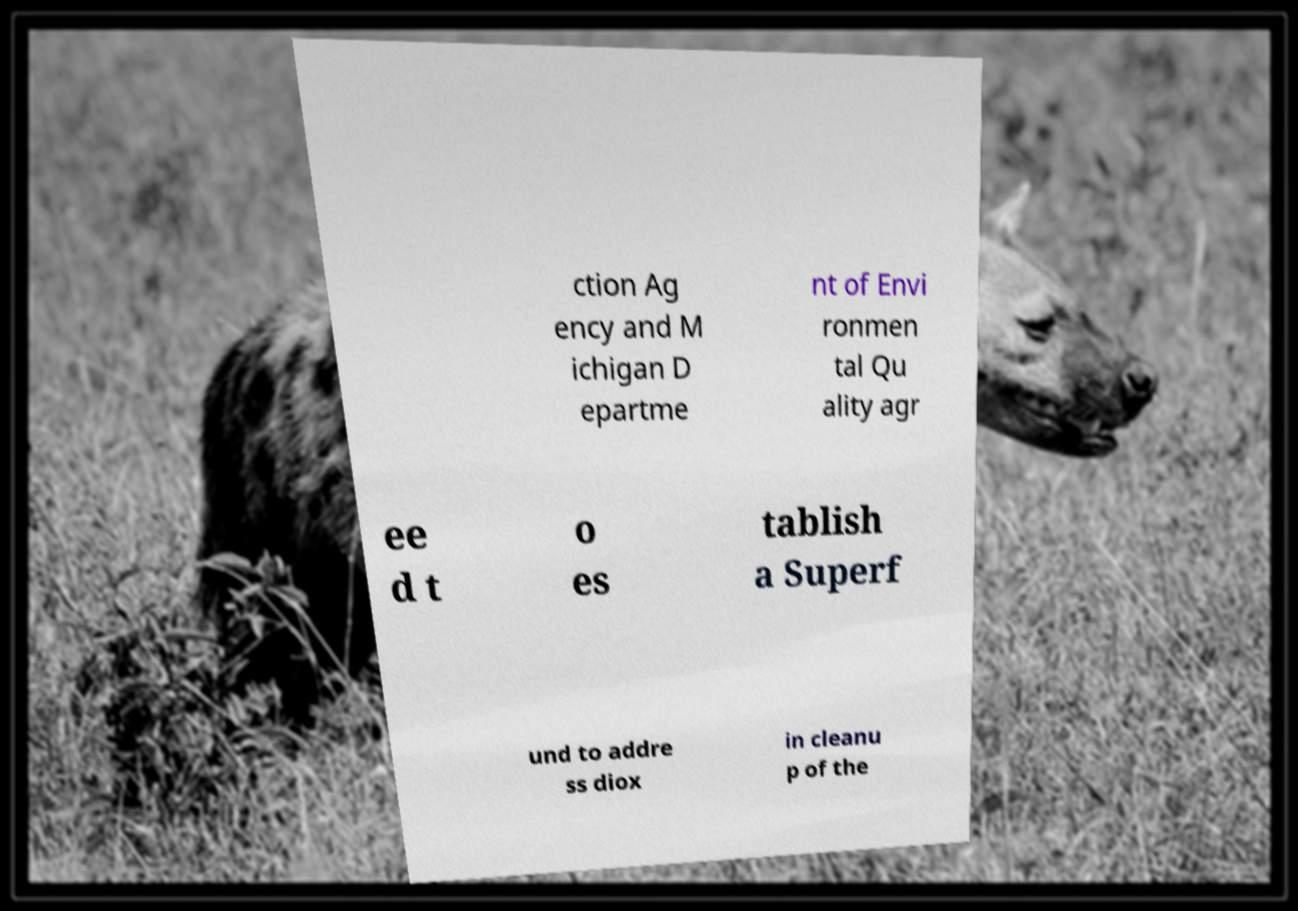Could you assist in decoding the text presented in this image and type it out clearly? ction Ag ency and M ichigan D epartme nt of Envi ronmen tal Qu ality agr ee d t o es tablish a Superf und to addre ss diox in cleanu p of the 